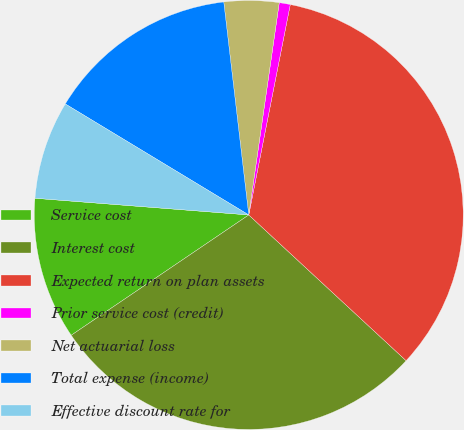Convert chart to OTSL. <chart><loc_0><loc_0><loc_500><loc_500><pie_chart><fcel>Service cost<fcel>Interest cost<fcel>Expected return on plan assets<fcel>Prior service cost (credit)<fcel>Net actuarial loss<fcel>Total expense (income)<fcel>Effective discount rate for<nl><fcel>10.72%<fcel>28.63%<fcel>33.79%<fcel>0.83%<fcel>4.13%<fcel>14.48%<fcel>7.42%<nl></chart> 